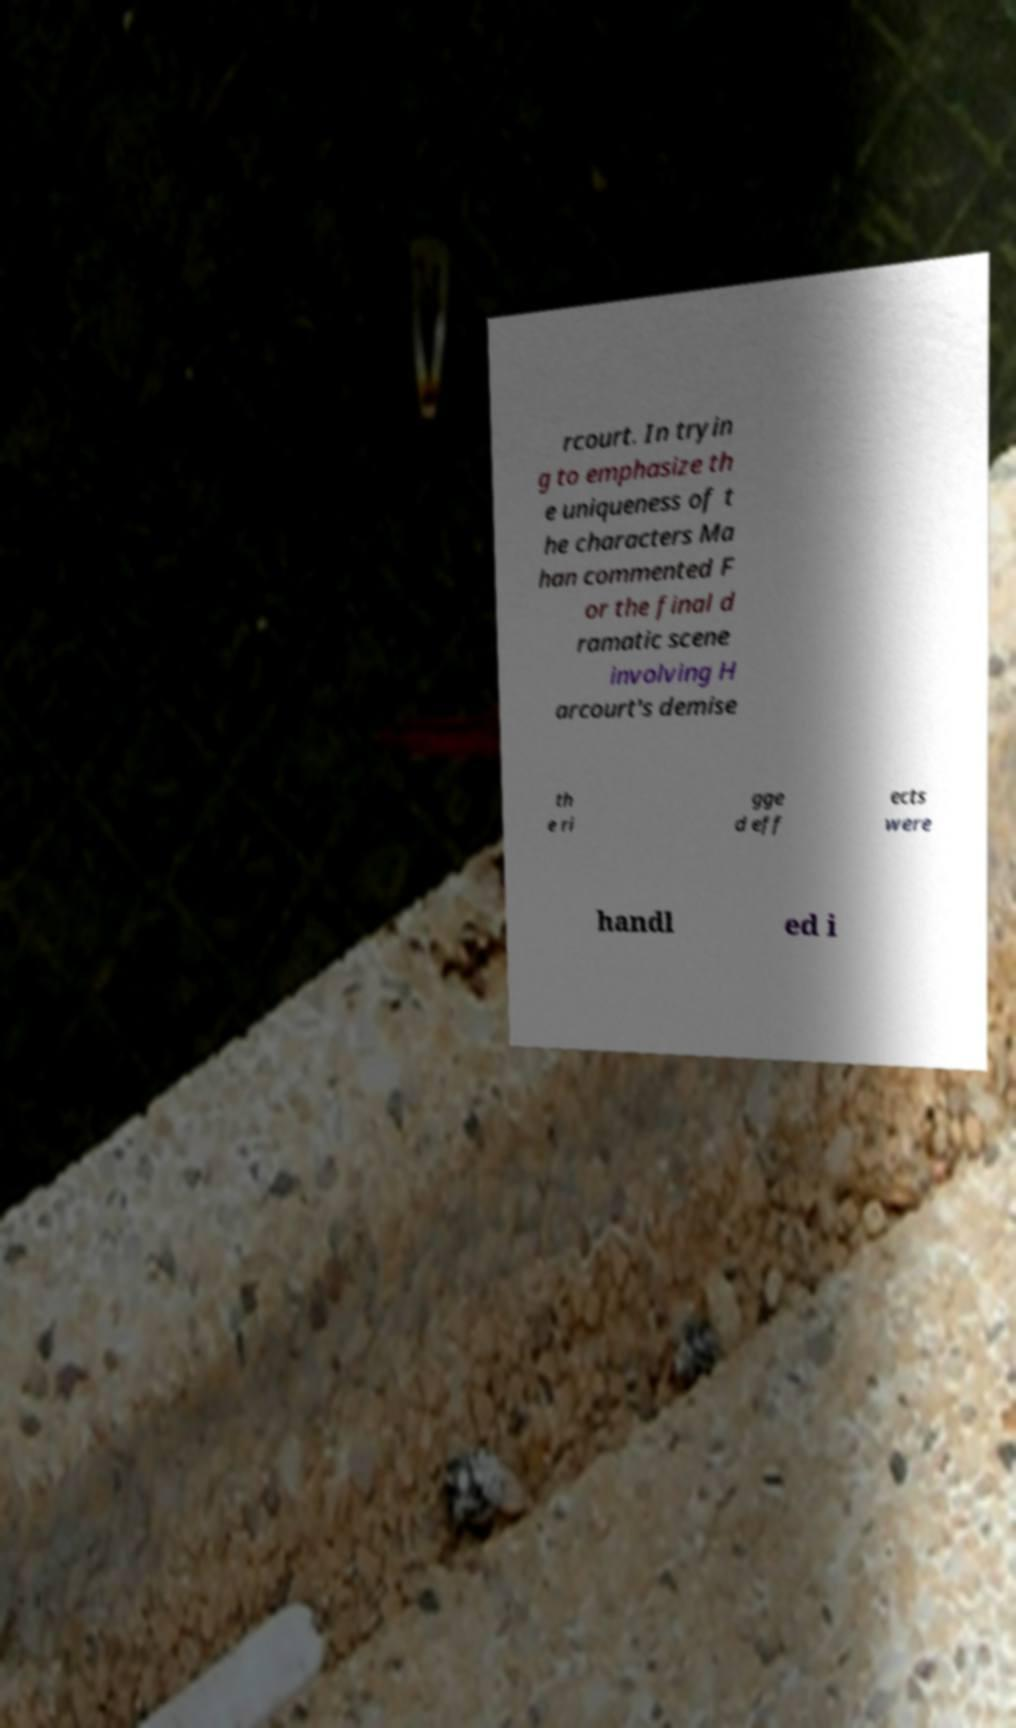Could you extract and type out the text from this image? rcourt. In tryin g to emphasize th e uniqueness of t he characters Ma han commented F or the final d ramatic scene involving H arcourt's demise th e ri gge d eff ects were handl ed i 